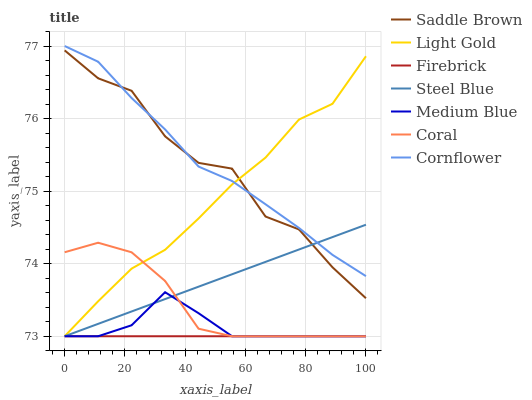Does Firebrick have the minimum area under the curve?
Answer yes or no. Yes. Does Cornflower have the maximum area under the curve?
Answer yes or no. Yes. Does Coral have the minimum area under the curve?
Answer yes or no. No. Does Coral have the maximum area under the curve?
Answer yes or no. No. Is Firebrick the smoothest?
Answer yes or no. Yes. Is Saddle Brown the roughest?
Answer yes or no. Yes. Is Coral the smoothest?
Answer yes or no. No. Is Coral the roughest?
Answer yes or no. No. Does Coral have the lowest value?
Answer yes or no. Yes. Does Saddle Brown have the lowest value?
Answer yes or no. No. Does Cornflower have the highest value?
Answer yes or no. Yes. Does Coral have the highest value?
Answer yes or no. No. Is Medium Blue less than Cornflower?
Answer yes or no. Yes. Is Saddle Brown greater than Medium Blue?
Answer yes or no. Yes. Does Steel Blue intersect Cornflower?
Answer yes or no. Yes. Is Steel Blue less than Cornflower?
Answer yes or no. No. Is Steel Blue greater than Cornflower?
Answer yes or no. No. Does Medium Blue intersect Cornflower?
Answer yes or no. No. 